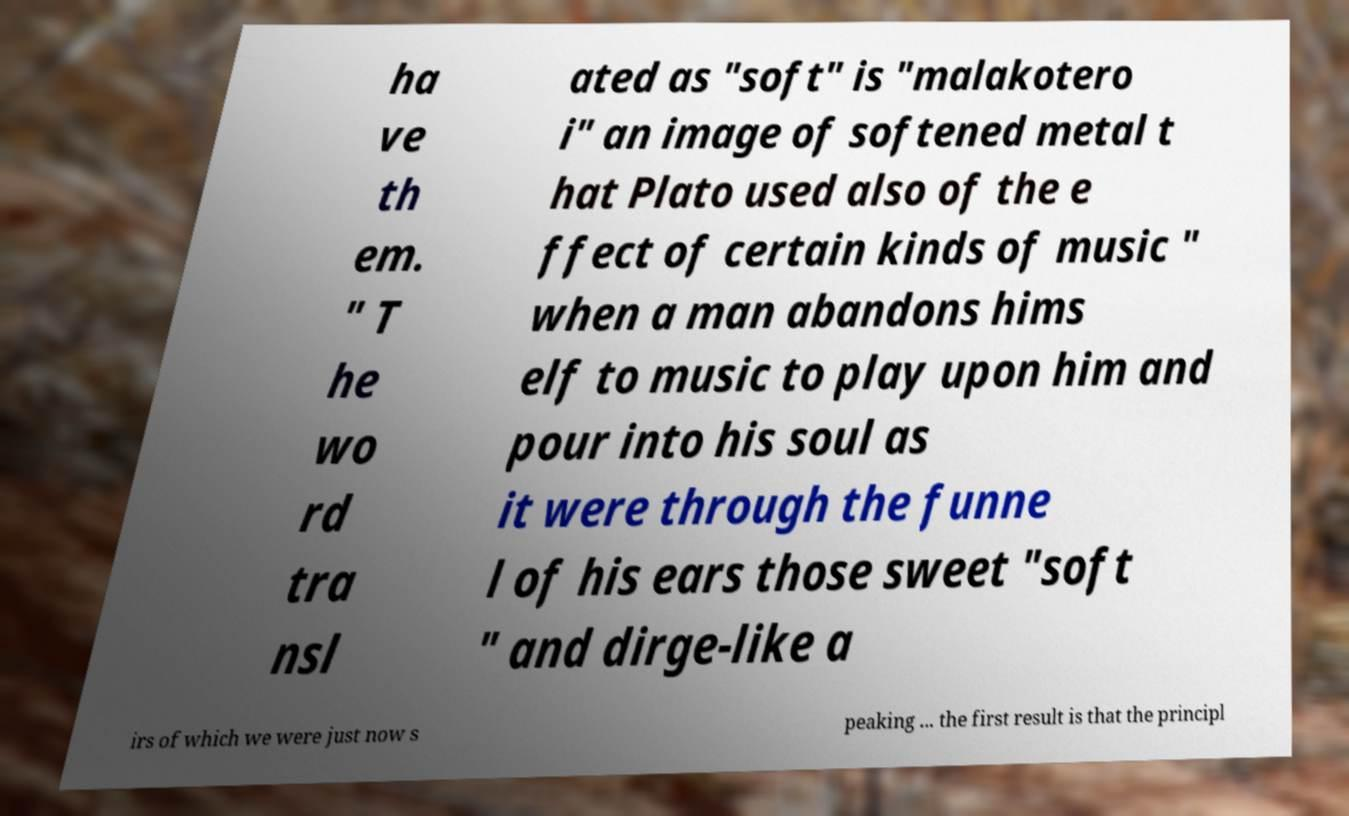Please identify and transcribe the text found in this image. ha ve th em. " T he wo rd tra nsl ated as "soft" is "malakotero i" an image of softened metal t hat Plato used also of the e ffect of certain kinds of music " when a man abandons hims elf to music to play upon him and pour into his soul as it were through the funne l of his ears those sweet "soft " and dirge-like a irs of which we were just now s peaking ... the first result is that the principl 